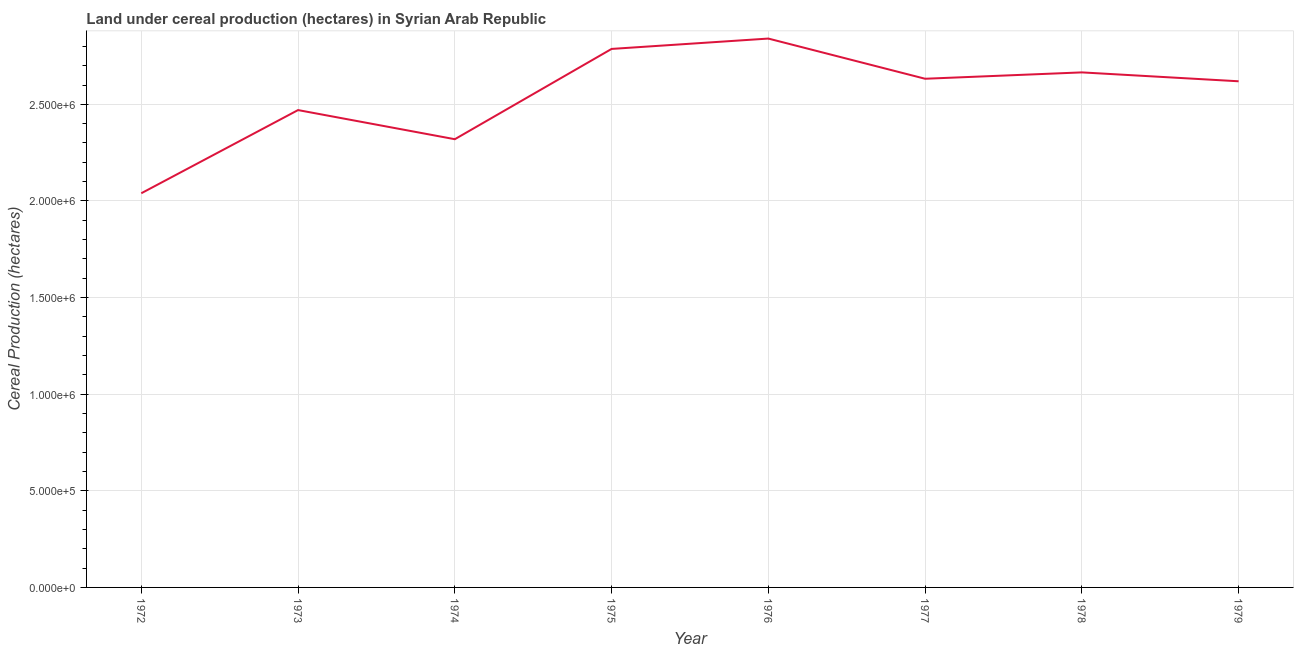What is the land under cereal production in 1978?
Ensure brevity in your answer.  2.67e+06. Across all years, what is the maximum land under cereal production?
Keep it short and to the point. 2.84e+06. Across all years, what is the minimum land under cereal production?
Provide a short and direct response. 2.04e+06. In which year was the land under cereal production maximum?
Provide a short and direct response. 1976. What is the sum of the land under cereal production?
Make the answer very short. 2.04e+07. What is the difference between the land under cereal production in 1972 and 1976?
Provide a succinct answer. -8.01e+05. What is the average land under cereal production per year?
Give a very brief answer. 2.55e+06. What is the median land under cereal production?
Provide a short and direct response. 2.63e+06. In how many years, is the land under cereal production greater than 300000 hectares?
Your answer should be very brief. 8. Do a majority of the years between 1979 and 1972 (inclusive) have land under cereal production greater than 2500000 hectares?
Keep it short and to the point. Yes. What is the ratio of the land under cereal production in 1977 to that in 1978?
Your answer should be compact. 0.99. Is the land under cereal production in 1972 less than that in 1979?
Provide a succinct answer. Yes. Is the difference between the land under cereal production in 1973 and 1978 greater than the difference between any two years?
Provide a short and direct response. No. What is the difference between the highest and the second highest land under cereal production?
Give a very brief answer. 5.36e+04. What is the difference between the highest and the lowest land under cereal production?
Ensure brevity in your answer.  8.01e+05. In how many years, is the land under cereal production greater than the average land under cereal production taken over all years?
Make the answer very short. 5. Does the graph contain any zero values?
Keep it short and to the point. No. Does the graph contain grids?
Offer a terse response. Yes. What is the title of the graph?
Offer a very short reply. Land under cereal production (hectares) in Syrian Arab Republic. What is the label or title of the Y-axis?
Provide a short and direct response. Cereal Production (hectares). What is the Cereal Production (hectares) of 1972?
Ensure brevity in your answer.  2.04e+06. What is the Cereal Production (hectares) in 1973?
Your response must be concise. 2.47e+06. What is the Cereal Production (hectares) of 1974?
Your answer should be compact. 2.32e+06. What is the Cereal Production (hectares) in 1975?
Keep it short and to the point. 2.79e+06. What is the Cereal Production (hectares) in 1976?
Ensure brevity in your answer.  2.84e+06. What is the Cereal Production (hectares) of 1977?
Your response must be concise. 2.63e+06. What is the Cereal Production (hectares) of 1978?
Provide a short and direct response. 2.67e+06. What is the Cereal Production (hectares) in 1979?
Provide a short and direct response. 2.62e+06. What is the difference between the Cereal Production (hectares) in 1972 and 1973?
Give a very brief answer. -4.30e+05. What is the difference between the Cereal Production (hectares) in 1972 and 1974?
Provide a short and direct response. -2.80e+05. What is the difference between the Cereal Production (hectares) in 1972 and 1975?
Provide a short and direct response. -7.47e+05. What is the difference between the Cereal Production (hectares) in 1972 and 1976?
Make the answer very short. -8.01e+05. What is the difference between the Cereal Production (hectares) in 1972 and 1977?
Provide a succinct answer. -5.93e+05. What is the difference between the Cereal Production (hectares) in 1972 and 1978?
Provide a short and direct response. -6.25e+05. What is the difference between the Cereal Production (hectares) in 1972 and 1979?
Give a very brief answer. -5.79e+05. What is the difference between the Cereal Production (hectares) in 1973 and 1974?
Offer a very short reply. 1.51e+05. What is the difference between the Cereal Production (hectares) in 1973 and 1975?
Provide a short and direct response. -3.16e+05. What is the difference between the Cereal Production (hectares) in 1973 and 1976?
Your answer should be compact. -3.70e+05. What is the difference between the Cereal Production (hectares) in 1973 and 1977?
Offer a very short reply. -1.62e+05. What is the difference between the Cereal Production (hectares) in 1973 and 1978?
Offer a terse response. -1.95e+05. What is the difference between the Cereal Production (hectares) in 1973 and 1979?
Offer a terse response. -1.49e+05. What is the difference between the Cereal Production (hectares) in 1974 and 1975?
Your answer should be very brief. -4.67e+05. What is the difference between the Cereal Production (hectares) in 1974 and 1976?
Your answer should be very brief. -5.21e+05. What is the difference between the Cereal Production (hectares) in 1974 and 1977?
Keep it short and to the point. -3.13e+05. What is the difference between the Cereal Production (hectares) in 1974 and 1978?
Provide a succinct answer. -3.46e+05. What is the difference between the Cereal Production (hectares) in 1974 and 1979?
Your response must be concise. -3.00e+05. What is the difference between the Cereal Production (hectares) in 1975 and 1976?
Ensure brevity in your answer.  -5.36e+04. What is the difference between the Cereal Production (hectares) in 1975 and 1977?
Give a very brief answer. 1.54e+05. What is the difference between the Cereal Production (hectares) in 1975 and 1978?
Ensure brevity in your answer.  1.21e+05. What is the difference between the Cereal Production (hectares) in 1975 and 1979?
Keep it short and to the point. 1.67e+05. What is the difference between the Cereal Production (hectares) in 1976 and 1977?
Ensure brevity in your answer.  2.08e+05. What is the difference between the Cereal Production (hectares) in 1976 and 1978?
Make the answer very short. 1.75e+05. What is the difference between the Cereal Production (hectares) in 1976 and 1979?
Your answer should be very brief. 2.21e+05. What is the difference between the Cereal Production (hectares) in 1977 and 1978?
Provide a short and direct response. -3.29e+04. What is the difference between the Cereal Production (hectares) in 1977 and 1979?
Keep it short and to the point. 1.31e+04. What is the difference between the Cereal Production (hectares) in 1978 and 1979?
Provide a succinct answer. 4.60e+04. What is the ratio of the Cereal Production (hectares) in 1972 to that in 1973?
Make the answer very short. 0.83. What is the ratio of the Cereal Production (hectares) in 1972 to that in 1974?
Keep it short and to the point. 0.88. What is the ratio of the Cereal Production (hectares) in 1972 to that in 1975?
Your response must be concise. 0.73. What is the ratio of the Cereal Production (hectares) in 1972 to that in 1976?
Your answer should be very brief. 0.72. What is the ratio of the Cereal Production (hectares) in 1972 to that in 1977?
Your answer should be very brief. 0.78. What is the ratio of the Cereal Production (hectares) in 1972 to that in 1978?
Provide a short and direct response. 0.77. What is the ratio of the Cereal Production (hectares) in 1972 to that in 1979?
Provide a succinct answer. 0.78. What is the ratio of the Cereal Production (hectares) in 1973 to that in 1974?
Provide a short and direct response. 1.06. What is the ratio of the Cereal Production (hectares) in 1973 to that in 1975?
Provide a short and direct response. 0.89. What is the ratio of the Cereal Production (hectares) in 1973 to that in 1976?
Offer a terse response. 0.87. What is the ratio of the Cereal Production (hectares) in 1973 to that in 1977?
Provide a short and direct response. 0.94. What is the ratio of the Cereal Production (hectares) in 1973 to that in 1978?
Provide a succinct answer. 0.93. What is the ratio of the Cereal Production (hectares) in 1973 to that in 1979?
Give a very brief answer. 0.94. What is the ratio of the Cereal Production (hectares) in 1974 to that in 1975?
Your answer should be compact. 0.83. What is the ratio of the Cereal Production (hectares) in 1974 to that in 1976?
Your answer should be compact. 0.82. What is the ratio of the Cereal Production (hectares) in 1974 to that in 1977?
Ensure brevity in your answer.  0.88. What is the ratio of the Cereal Production (hectares) in 1974 to that in 1978?
Offer a very short reply. 0.87. What is the ratio of the Cereal Production (hectares) in 1974 to that in 1979?
Your answer should be very brief. 0.89. What is the ratio of the Cereal Production (hectares) in 1975 to that in 1976?
Your answer should be compact. 0.98. What is the ratio of the Cereal Production (hectares) in 1975 to that in 1977?
Make the answer very short. 1.06. What is the ratio of the Cereal Production (hectares) in 1975 to that in 1978?
Your answer should be very brief. 1.05. What is the ratio of the Cereal Production (hectares) in 1975 to that in 1979?
Provide a succinct answer. 1.06. What is the ratio of the Cereal Production (hectares) in 1976 to that in 1977?
Your response must be concise. 1.08. What is the ratio of the Cereal Production (hectares) in 1976 to that in 1978?
Ensure brevity in your answer.  1.07. What is the ratio of the Cereal Production (hectares) in 1976 to that in 1979?
Your answer should be compact. 1.08. What is the ratio of the Cereal Production (hectares) in 1977 to that in 1979?
Give a very brief answer. 1. What is the ratio of the Cereal Production (hectares) in 1978 to that in 1979?
Offer a terse response. 1.02. 